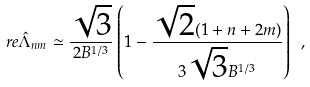<formula> <loc_0><loc_0><loc_500><loc_500>\ r e \hat { \Lambda } _ { n m } \simeq \frac { \sqrt { 3 } } { 2 B ^ { 1 / 3 } } \left ( 1 - \frac { \sqrt { 2 } ( 1 + n + 2 m ) } { 3 \sqrt { 3 } B ^ { 1 / 3 } } \right ) \ ,</formula> 